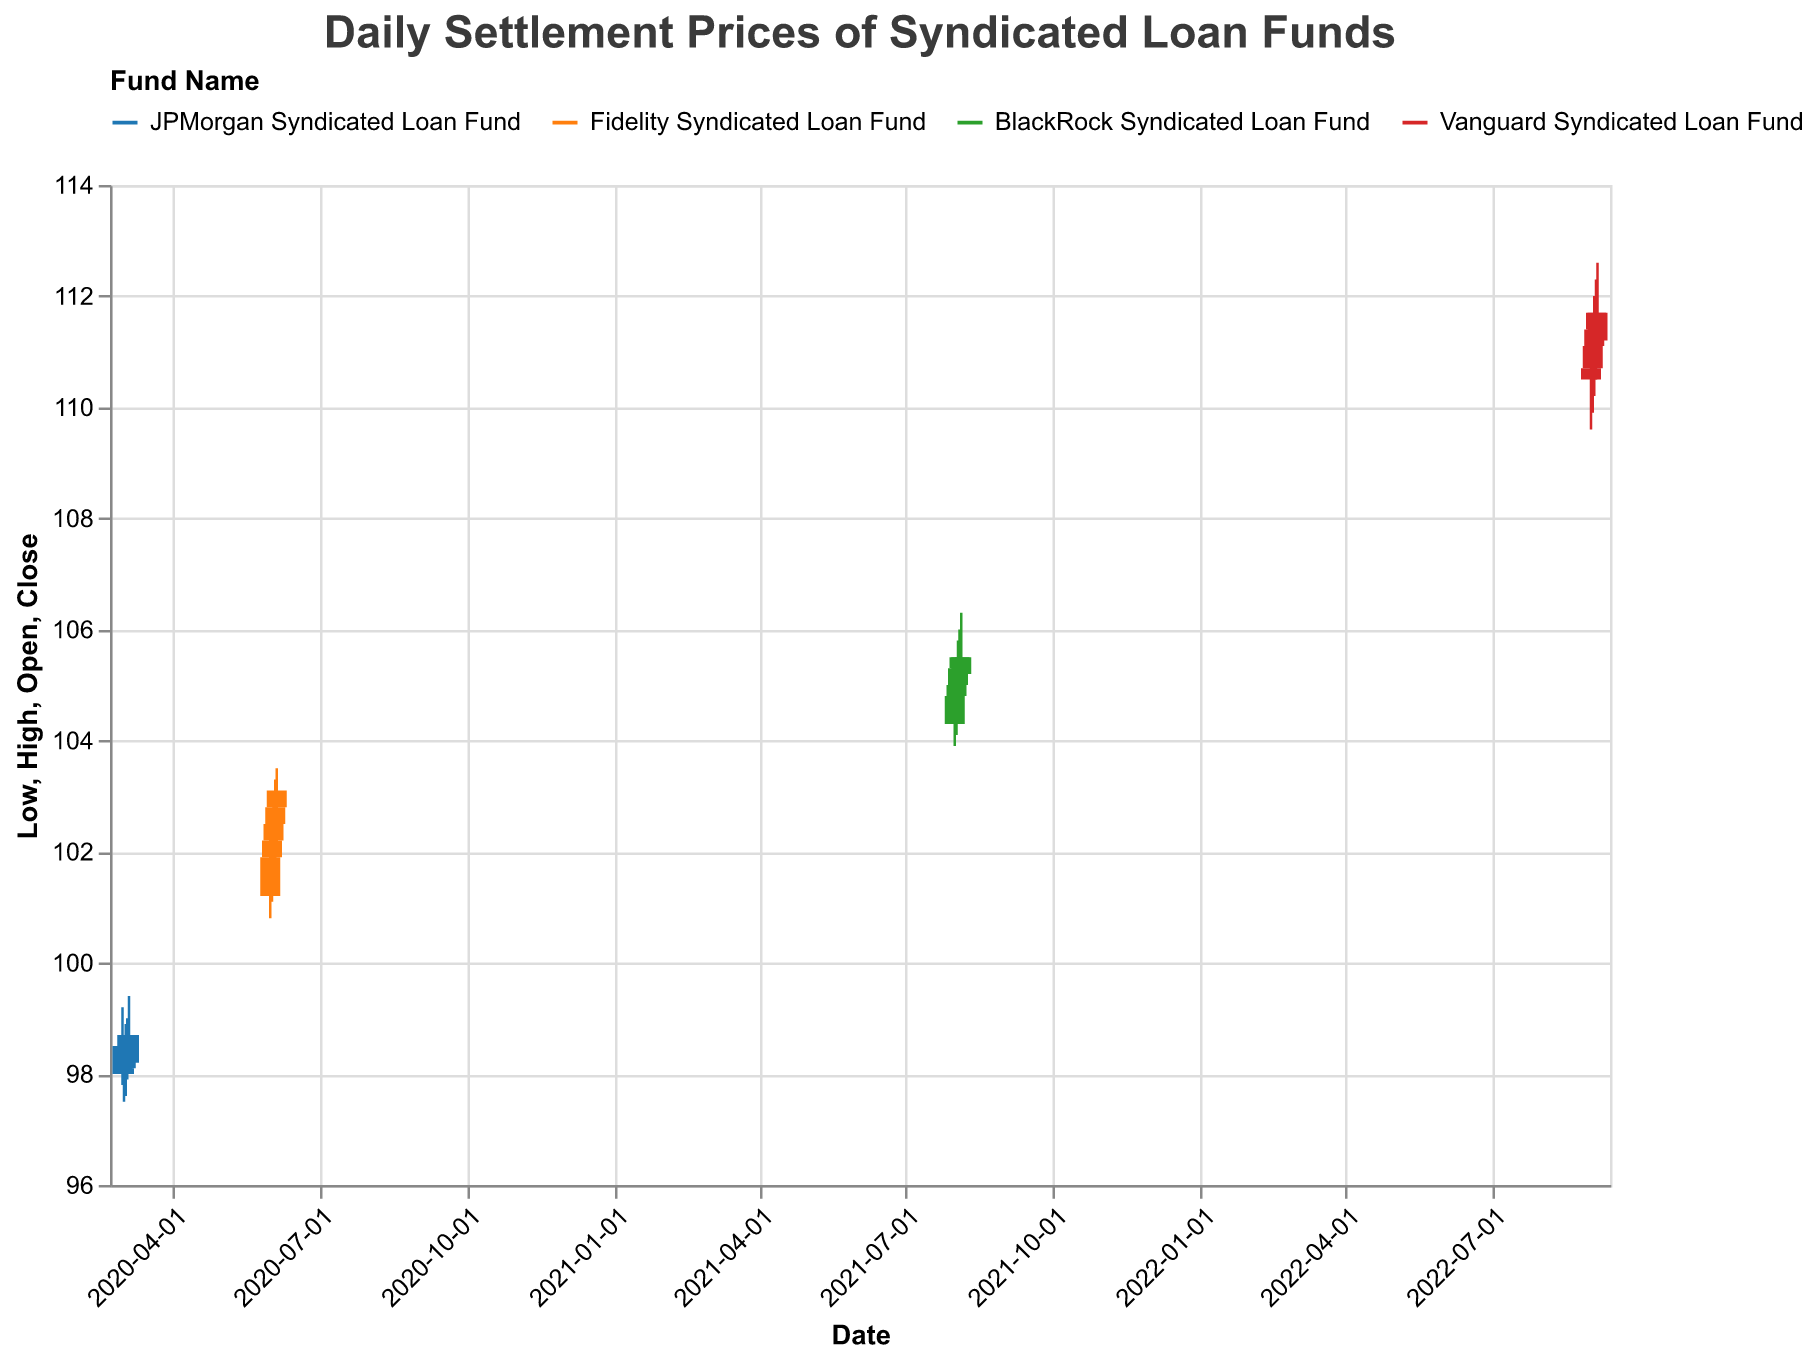What is the title of the plot? The title is displayed at the top of the plot in a larger, bold font, indicating what the data represents.
Answer: Daily Settlement Prices of Syndicated Loan Funds Which fund has the highest starting date in the data? Looking at the x-axis for the starting dates, Vanguard Syndicated Loan Fund starts on 2022-09-01, which is the latest date compared to others.
Answer: Vanguard Syndicated Loan Fund What is the color used for the JPMorgan Syndicated Loan Fund? The legend at the top of the plot assigns the color blue to the JPMorgan Syndicated Loan Fund.
Answer: blue Between 2020-03-01 and 2020-03-05, did the JPMorgan Syndicated Loan Fund have more days closing higher than opening, or vice versa? Look at the bars; they are colored and either filled or not. Filled bars (close lower than open) are found on 2020-03-01, 2020-03-02, and 2020-03-05. Unfilled bars (close higher than open) are found on 2020-03-03 and 2020-03-04.
Answer: more days closing lower Which fund shows the highest volatility during the plotted period, and how is it determined? Volatility is indicated by the length of the wicks between the high and low values. Calculate the differences for each fund. Vanguard Syndicated Loan Fund (2022-09-01 to 2022-09-05) shows the largest variations between high and low values.
Answer: Vanguard Syndicated Loan Fund What is the lowest 'Low' price recorded, and for which date and fund? Scanning the plot, identify the lowest points on the y-axis. The lowest 'Low' price is 97.5 on 2020-03-02 for the JPMorgan Syndicated Loan Fund.
Answer: 97.5 on 2020-03-02 for JPMorgan Syndicated Loan Fund On 2021-08-04, did the BlackRock Syndicated Loan Fund's closing price exceed its opening price? Compare the closing price (top of bar) with the opening price (bottom of the bar) on 2021-08-04. The closing price is higher than the opening price.
Answer: Yes Which fund has an overall upward trend in the provided dates? Spotting an upward trend involves looking for a general increase from the first recorded close to the last. Fidelity Syndicated Loan Fund (from 101.9 to 103.1) shows a consistent upward trend.
Answer: Fidelity Syndicated Loan Fund How many total data points are plotted in the figure? Count each represented day; since each day is a single data point and there are four funds, add up their respective data points: 5 days for JPMorgan, 5 days for Fidelity, 5 days for BlackRock, and 5 days for Vanguard.
Answer: 20 data points 